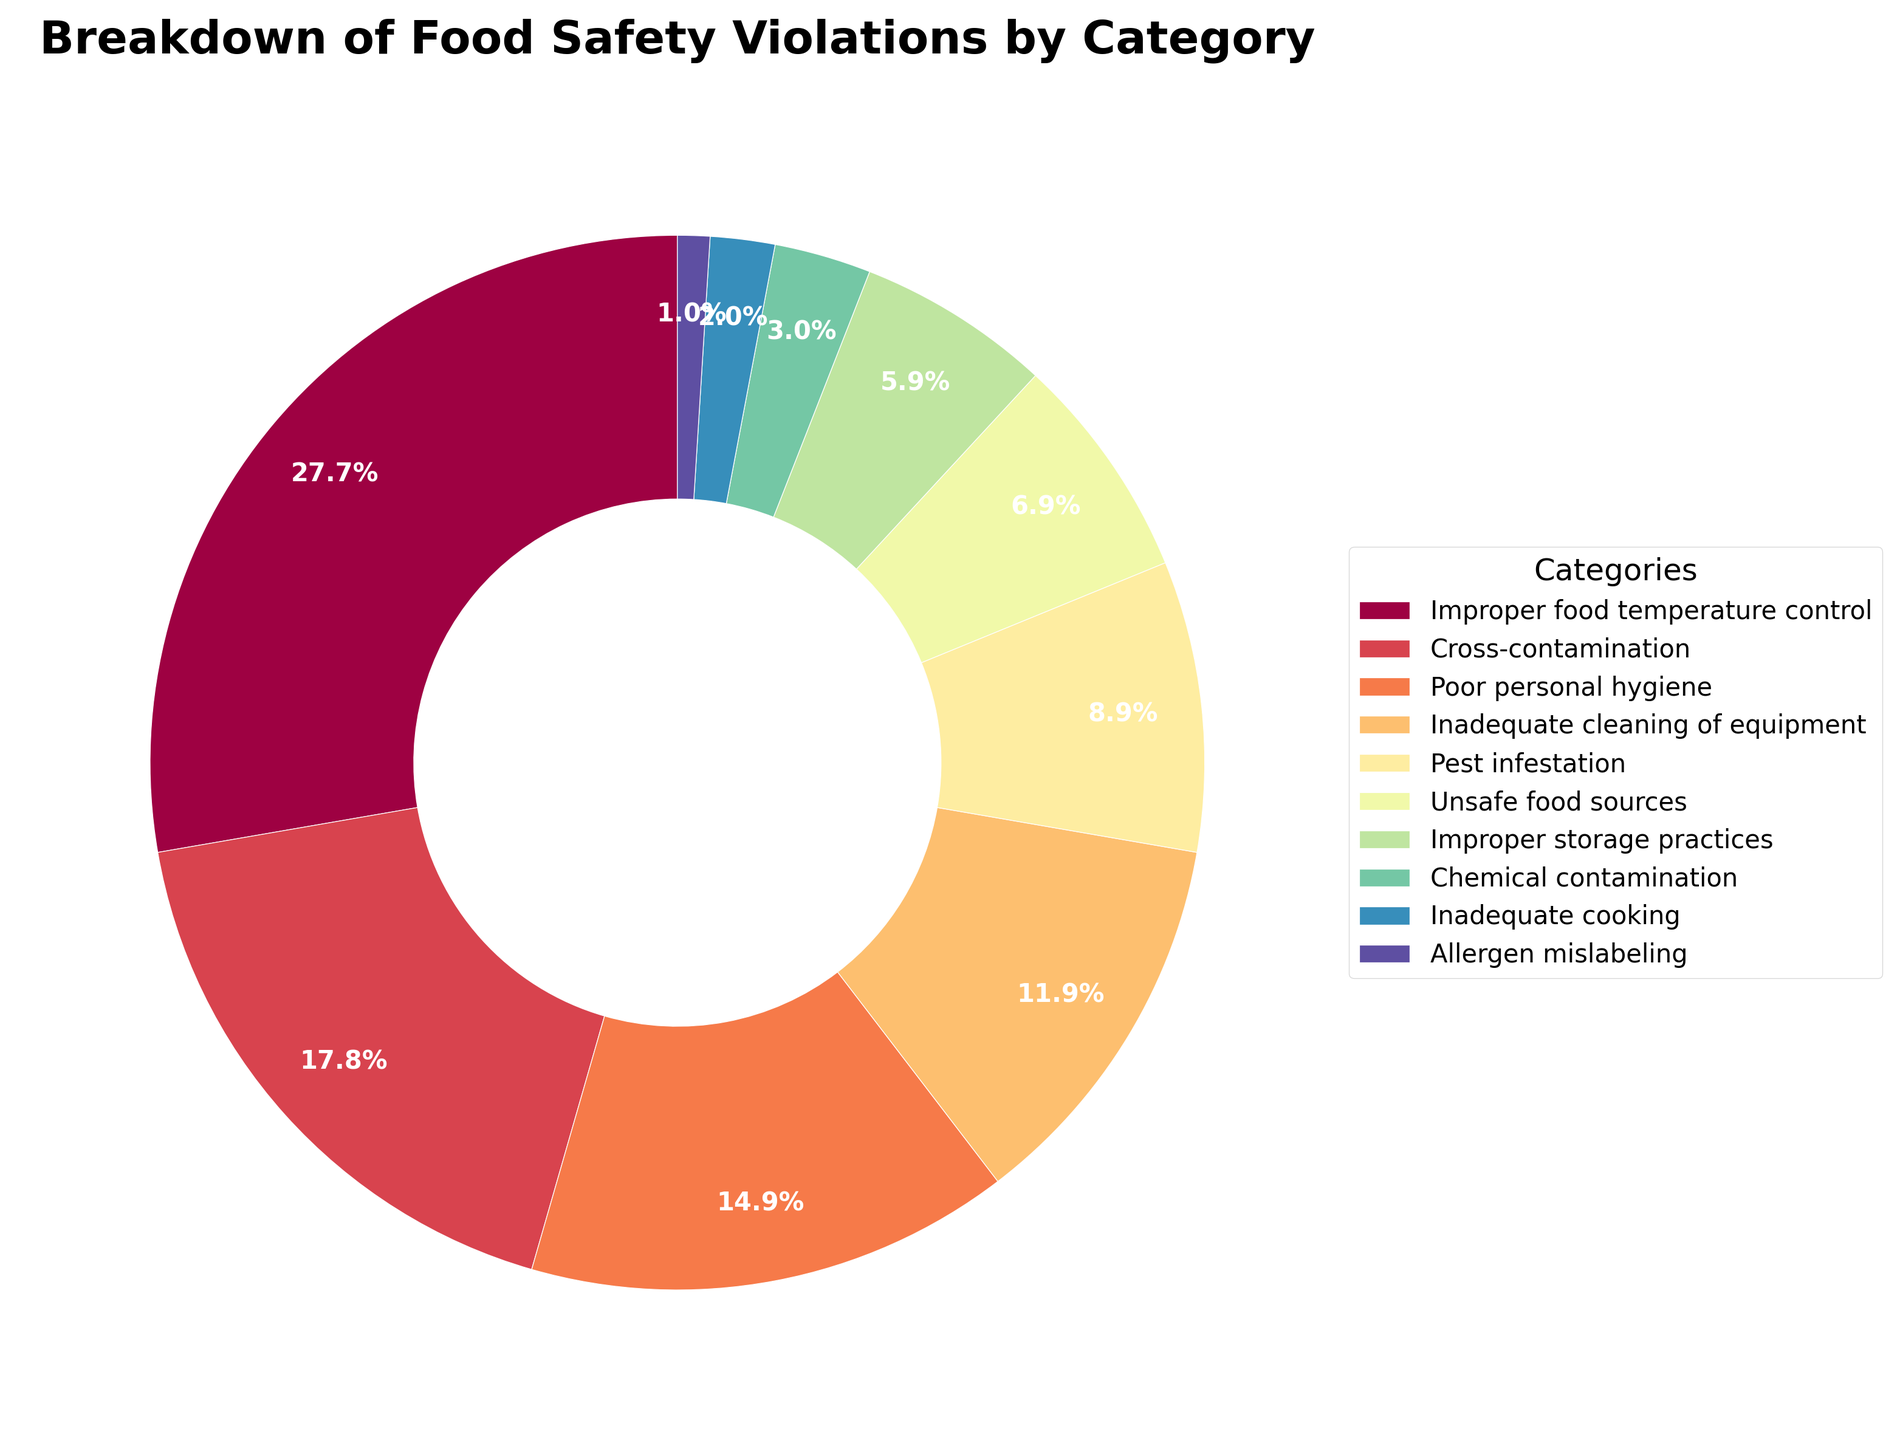Which category has the highest percentage of food safety violations? The largest wedge in the pie chart corresponds to "Improper food temperature control" with the largest percentage display, which is 28%.
Answer: Improper food temperature control What are the total percentages of the top three categories combined? Identify the top three categories in the pie chart: "Improper food temperature control" (28%), "Cross-contamination" (18%), and "Poor personal hygiene" (15%). Sum these percentages: 28 + 18 + 15 = 61%.
Answer: 61% How does the percentage of pest infestation compare to improper storage practices? Find the percentages for "Pest infestation" (9%) and "Improper storage practices" (6%). Compare them: 9% is greater than 6%.
Answer: Pest infestation is greater Which categories have a percentage less than 5%? Identify the wedges in the pie chart with percentages smaller than 5%: "Chemical contamination" (3%), "Inadequate cooking" (2%), and "Allergen mislabeling" (1%).
Answer: Chemical contamination, Inadequate cooking, Allergen mislabeling What is the difference in percentage between inadequate cleaning of equipment and unsafe food sources? Identify the percentages for "Inadequate cleaning of equipment" (12%) and "Unsafe food sources" (7%). Calculate the difference: 12 - 7 = 5.
Answer: 5% How many categories have a violation percentage of 10% or higher? Count the wedges in the pie chart with a percentage ≥ 10%: "Improper food temperature control" (28%), "Cross-contamination" (18%), "Poor personal hygiene" (15%), and "Inadequate cleaning of equipment" (12%). This yields a total of 4 categories.
Answer: 4 What is the combined percentage of the two smallest categories? Identify the two smallest categories: "Inadequate cooking" (2%) and "Allergen mislabeling" (1%). Sum these percentages: 2 + 1 = 3%.
Answer: 3% Which category is represented in green on the pie chart? Locate the wedge colored green and find its corresponding label. The pie chart shows "Inadequate cooking" with a green color.
Answer: Inadequate cooking 